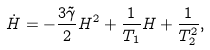<formula> <loc_0><loc_0><loc_500><loc_500>\dot { H } = - \frac { 3 \tilde { \gamma } } { 2 } H ^ { 2 } + \frac { 1 } { T _ { 1 } } H + \frac { 1 } { T _ { 2 } ^ { 2 } } ,</formula> 